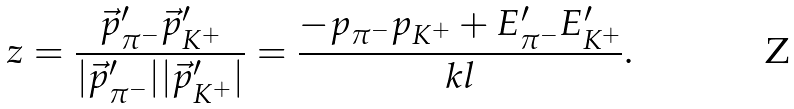Convert formula to latex. <formula><loc_0><loc_0><loc_500><loc_500>z = \frac { \vec { p } _ { \pi ^ { - } } ^ { \prime } \vec { p } _ { K ^ { + } } ^ { \prime } } { | \vec { p } _ { \pi ^ { - } } ^ { \prime } | | \vec { p } _ { K ^ { + } } ^ { \prime } | } = \frac { - p _ { \pi ^ { - } } p _ { K ^ { + } } + E _ { \pi ^ { - } } ^ { \prime } E _ { K ^ { + } } ^ { \prime } } { k l } .</formula> 